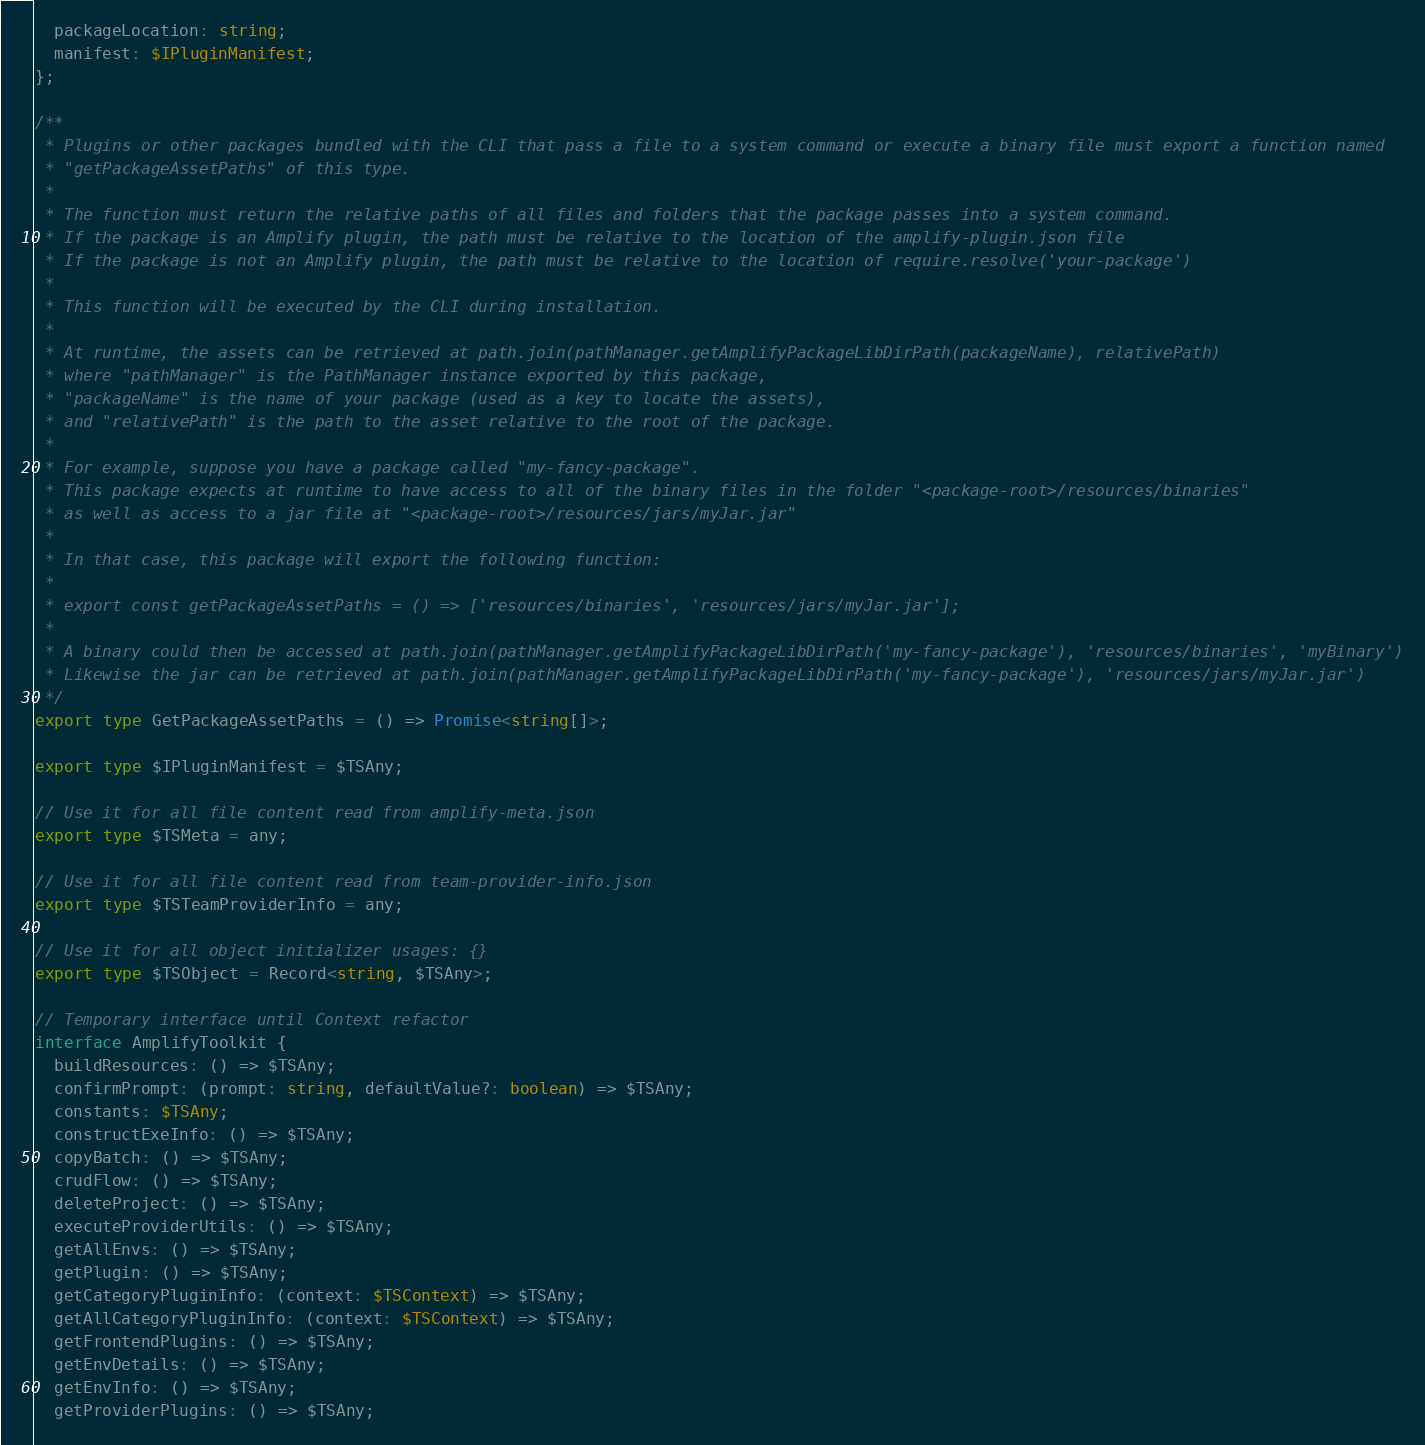<code> <loc_0><loc_0><loc_500><loc_500><_TypeScript_>  packageLocation: string;
  manifest: $IPluginManifest;
};

/**
 * Plugins or other packages bundled with the CLI that pass a file to a system command or execute a binary file must export a function named
 * "getPackageAssetPaths" of this type.
 *
 * The function must return the relative paths of all files and folders that the package passes into a system command.
 * If the package is an Amplify plugin, the path must be relative to the location of the amplify-plugin.json file
 * If the package is not an Amplify plugin, the path must be relative to the location of require.resolve('your-package')
 *
 * This function will be executed by the CLI during installation.
 *
 * At runtime, the assets can be retrieved at path.join(pathManager.getAmplifyPackageLibDirPath(packageName), relativePath)
 * where "pathManager" is the PathManager instance exported by this package,
 * "packageName" is the name of your package (used as a key to locate the assets),
 * and "relativePath" is the path to the asset relative to the root of the package.
 *
 * For example, suppose you have a package called "my-fancy-package".
 * This package expects at runtime to have access to all of the binary files in the folder "<package-root>/resources/binaries"
 * as well as access to a jar file at "<package-root>/resources/jars/myJar.jar"
 *
 * In that case, this package will export the following function:
 *
 * export const getPackageAssetPaths = () => ['resources/binaries', 'resources/jars/myJar.jar'];
 *
 * A binary could then be accessed at path.join(pathManager.getAmplifyPackageLibDirPath('my-fancy-package'), 'resources/binaries', 'myBinary')
 * Likewise the jar can be retrieved at path.join(pathManager.getAmplifyPackageLibDirPath('my-fancy-package'), 'resources/jars/myJar.jar')
 */
export type GetPackageAssetPaths = () => Promise<string[]>;

export type $IPluginManifest = $TSAny;

// Use it for all file content read from amplify-meta.json
export type $TSMeta = any;

// Use it for all file content read from team-provider-info.json
export type $TSTeamProviderInfo = any;

// Use it for all object initializer usages: {}
export type $TSObject = Record<string, $TSAny>;

// Temporary interface until Context refactor
interface AmplifyToolkit {
  buildResources: () => $TSAny;
  confirmPrompt: (prompt: string, defaultValue?: boolean) => $TSAny;
  constants: $TSAny;
  constructExeInfo: () => $TSAny;
  copyBatch: () => $TSAny;
  crudFlow: () => $TSAny;
  deleteProject: () => $TSAny;
  executeProviderUtils: () => $TSAny;
  getAllEnvs: () => $TSAny;
  getPlugin: () => $TSAny;
  getCategoryPluginInfo: (context: $TSContext) => $TSAny;
  getAllCategoryPluginInfo: (context: $TSContext) => $TSAny;
  getFrontendPlugins: () => $TSAny;
  getEnvDetails: () => $TSAny;
  getEnvInfo: () => $TSAny;
  getProviderPlugins: () => $TSAny;</code> 